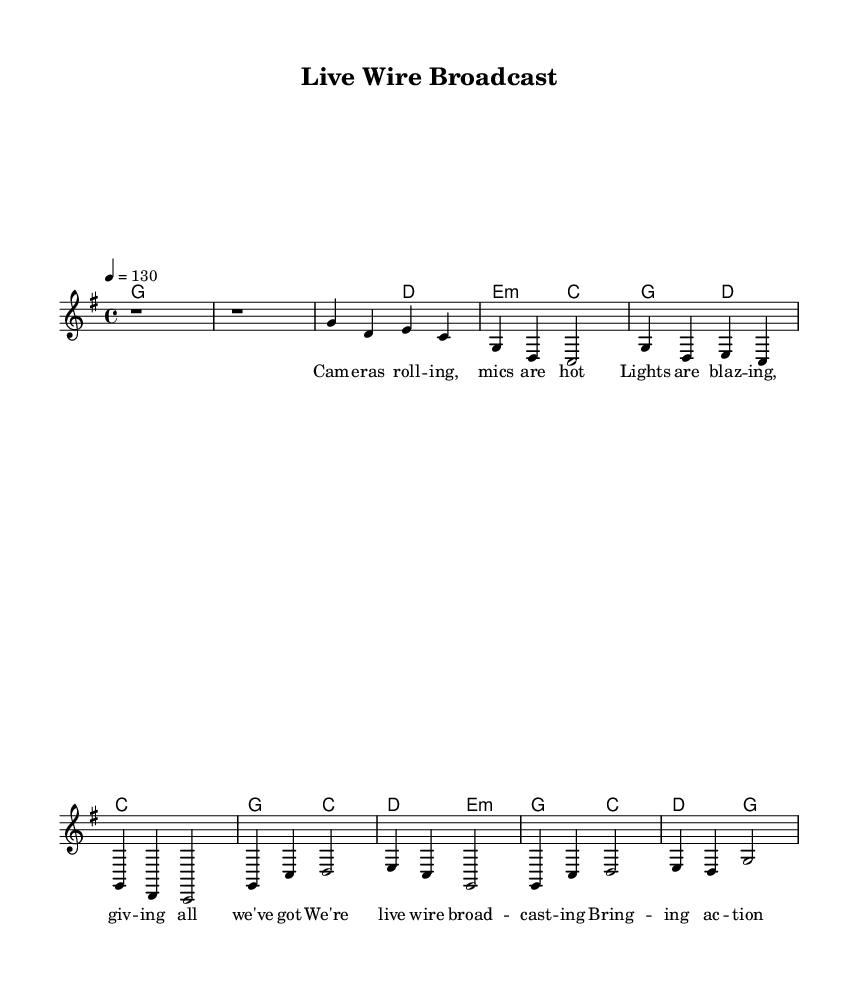What is the key signature of this music? The key signature is one sharp, which indicates G major. In the music score, the presence of one sharp directly relates to the note F#, which is a characteristic of the G major key.
Answer: G major What is the time signature of this music? The time signature is indicated as 4/4, meaning there are four beats in each measure and the quarter note gets one beat. This can be inferred from the notation visibly shown at the beginning of the score.
Answer: 4/4 What is the tempo marking of this music? The tempo marking indicates a speed of 130 beats per minute, which is shown in the score next to the tempo indication. This reflects how quickly the music should be played.
Answer: 130 How many measures are in the verse section? The verse section consists of four measures, which can be counted directly from the visual grouping of notes in the score labeled as the verse. Each line typically represents a measure in the score.
Answer: Four measures How many chords are used in the chorus? The chorus employs four different chords: G, C, D, and E minor. This can be deduced by looking at the chord changes written above the melody and counting each distinct chord noted during the chorus section.
Answer: Four chords What lyrical theme is presented in the chorus? The chorus emphasizes the theme of live broadcasting and action, as indicated by the text that describes "live wire broadcasting" and "bringing action to the nation." This is observed in the lyrics directly provided in the score.
Answer: Live broadcasting What musical genre does this piece represent? The piece is categorized as Country Rock, a genre defined by its blend of country music and rock elements, as indicated in the inquiry's context and the upbeat anthemic style of the melody and lyrics.
Answer: Country Rock 